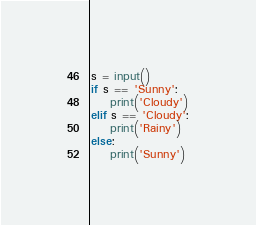Convert code to text. <code><loc_0><loc_0><loc_500><loc_500><_Python_>s = input()
if s == 'Sunny':
    print('Cloudy')
elif s == 'Cloudy':
    print('Rainy')
else:
    print('Sunny')
</code> 